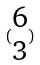Convert formula to latex. <formula><loc_0><loc_0><loc_500><loc_500>( \begin{matrix} 6 \\ 3 \end{matrix} )</formula> 